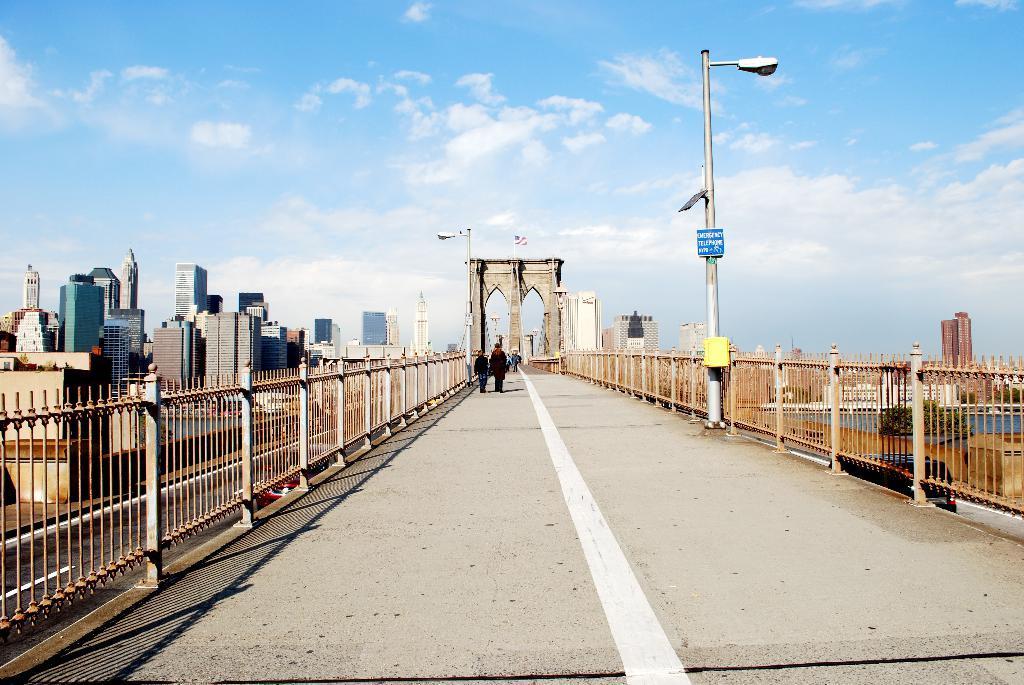How would you summarize this image in a sentence or two? In this picture we can see group of people on the bridge, beside to them we can see fence, few poles, lights and buildings, on the right side of the image we can see a car and water, and also we can see clouds. 